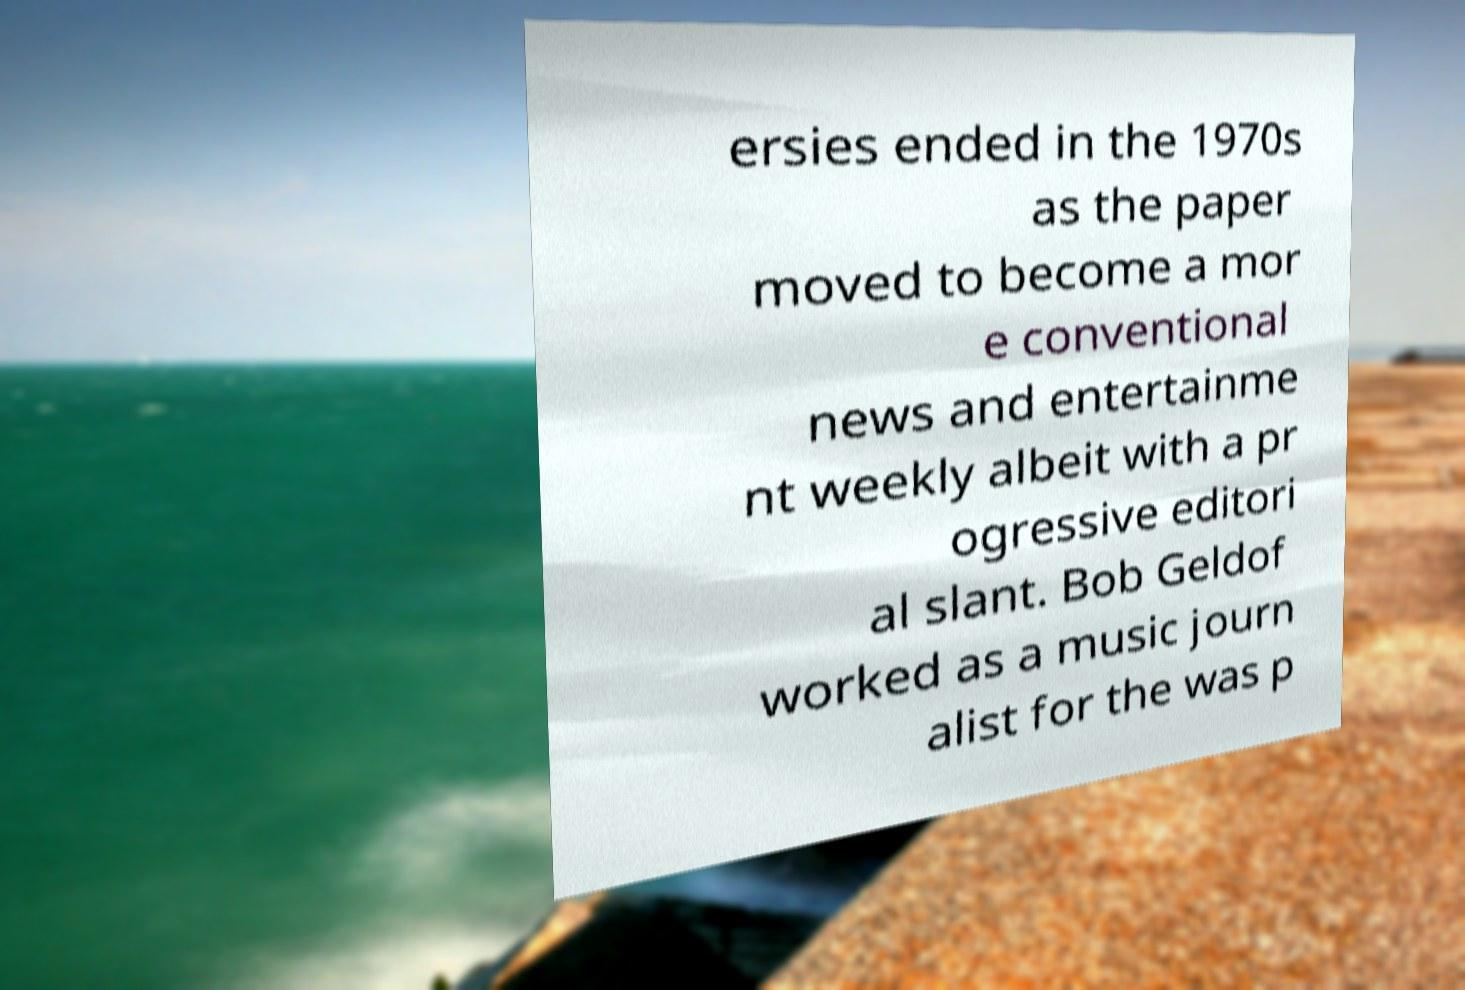Could you assist in decoding the text presented in this image and type it out clearly? ersies ended in the 1970s as the paper moved to become a mor e conventional news and entertainme nt weekly albeit with a pr ogressive editori al slant. Bob Geldof worked as a music journ alist for the was p 